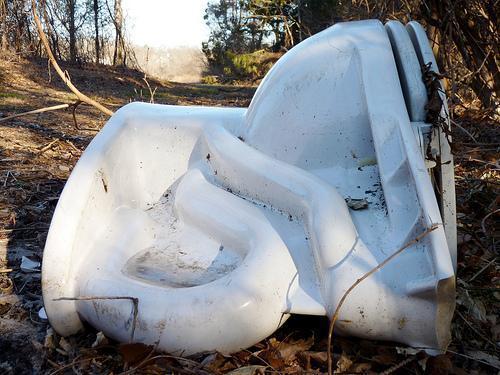How many toilets are there?
Give a very brief answer. 1. 